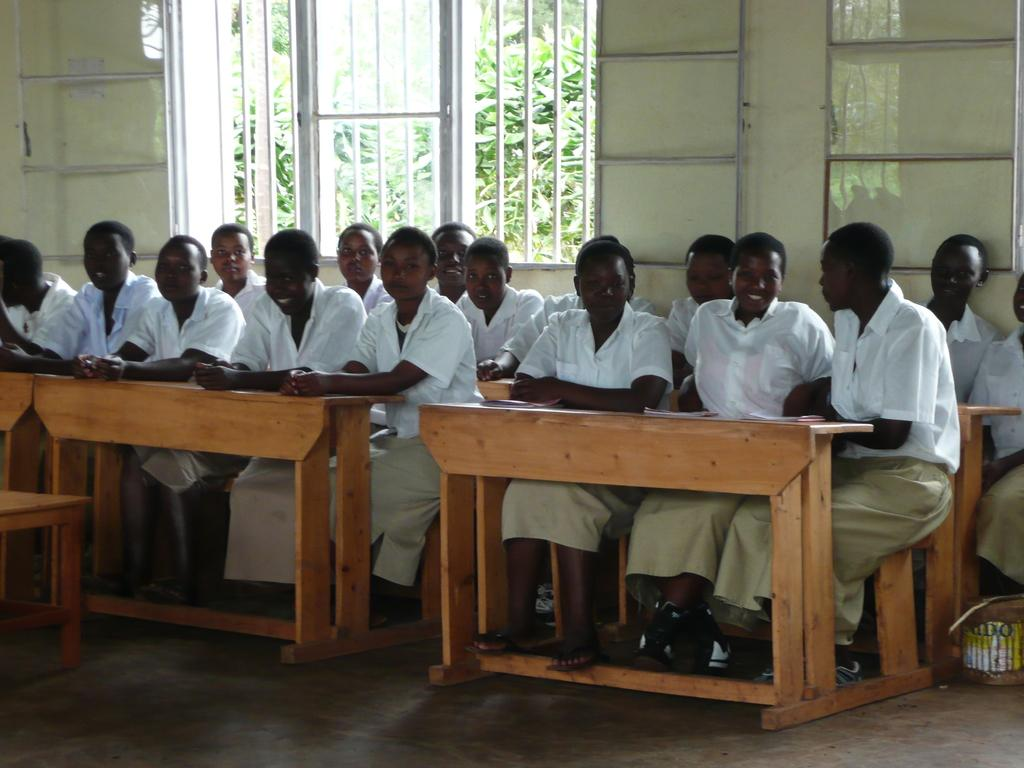How many people are sitting on the bench in the image? There are many people sitting on the bench in the image. What are the people wearing? The people are wearing white shirts. What can be seen behind the bench? There is a window behind the bench. What is visible outside the building? There are trees outside the building. What type of copper material is being used to provide comfort to the people sitting on the bench? There is no copper material mentioned in the image, and the people's comfort is not discussed. 